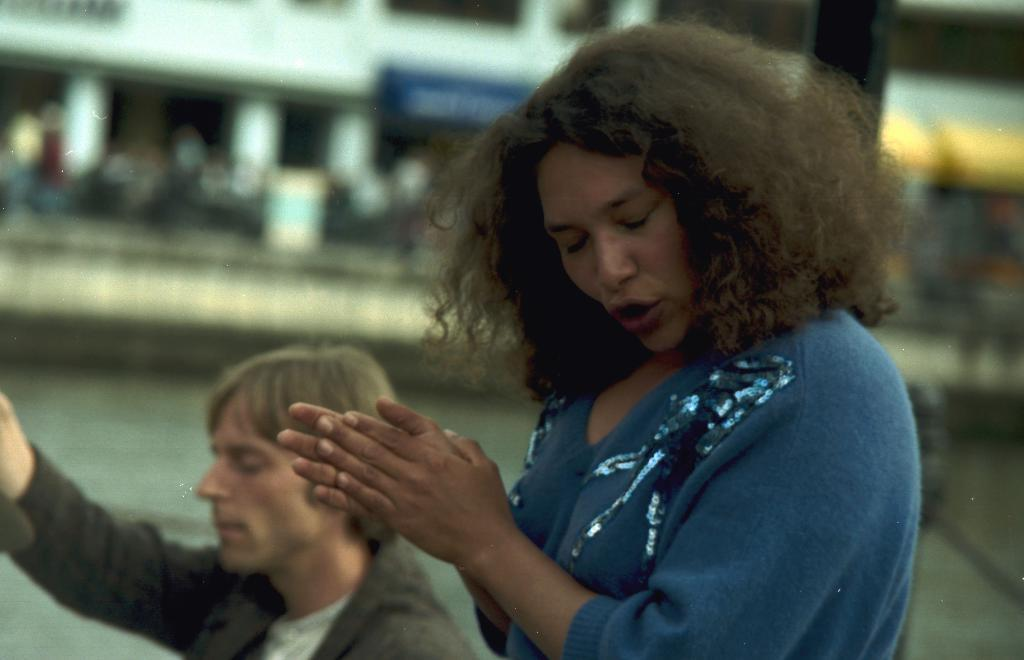What is the woman in the image doing? The woman is clapping in the image. Can you describe the other person in the image? There is another person in the image, but no specific details are provided about them. How would you describe the background of the image? The background is blurred in the image. What type of writing can be seen on the sand in the image? There is no sand or writing present in the image. What part of the person's flesh is visible in the image? There is no flesh visible in the image, as the focus is on the woman clapping and the other person. 